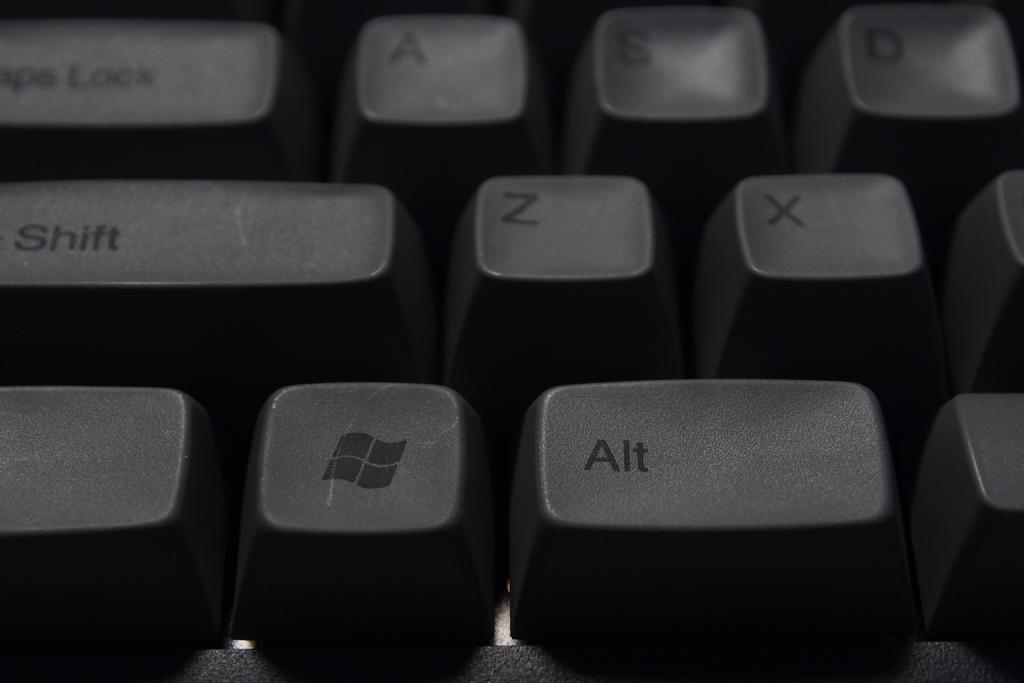What is the lowest key shown?
Keep it short and to the point. Alt. What is the highest key shown?
Your response must be concise. A. 